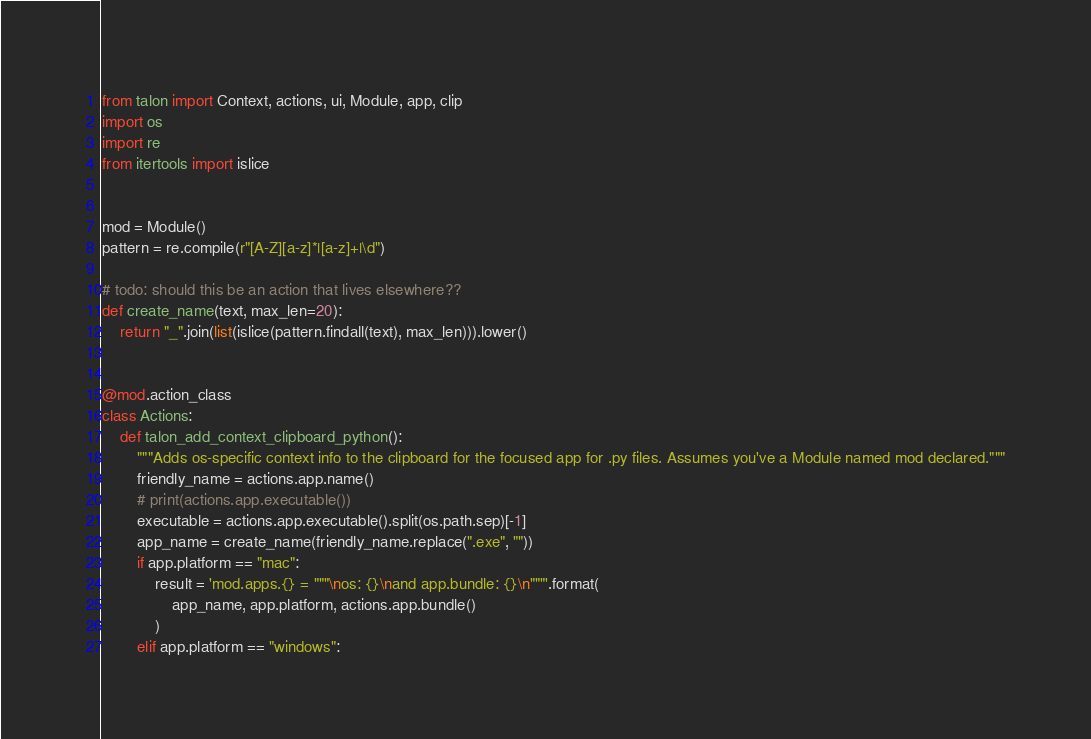Convert code to text. <code><loc_0><loc_0><loc_500><loc_500><_Python_>from talon import Context, actions, ui, Module, app, clip
import os
import re
from itertools import islice


mod = Module()
pattern = re.compile(r"[A-Z][a-z]*|[a-z]+|\d")

# todo: should this be an action that lives elsewhere??
def create_name(text, max_len=20):
    return "_".join(list(islice(pattern.findall(text), max_len))).lower()


@mod.action_class
class Actions:
    def talon_add_context_clipboard_python():
        """Adds os-specific context info to the clipboard for the focused app for .py files. Assumes you've a Module named mod declared."""
        friendly_name = actions.app.name()
        # print(actions.app.executable())
        executable = actions.app.executable().split(os.path.sep)[-1]
        app_name = create_name(friendly_name.replace(".exe", ""))
        if app.platform == "mac":
            result = 'mod.apps.{} = """\nos: {}\nand app.bundle: {}\n"""'.format(
                app_name, app.platform, actions.app.bundle()
            )
        elif app.platform == "windows":</code> 